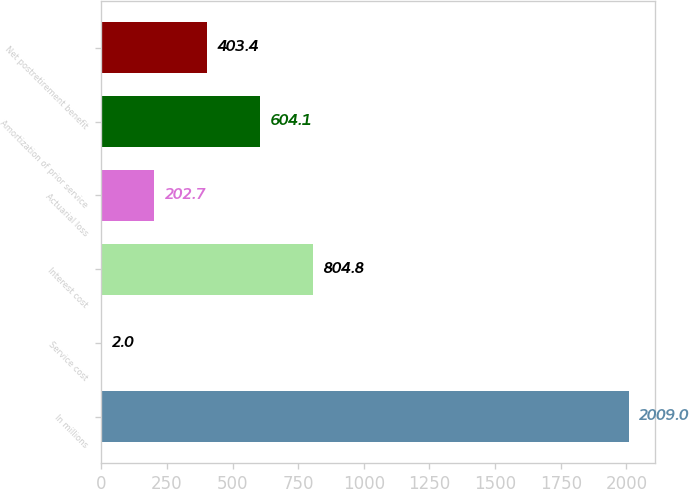Convert chart. <chart><loc_0><loc_0><loc_500><loc_500><bar_chart><fcel>In millions<fcel>Service cost<fcel>Interest cost<fcel>Actuarial loss<fcel>Amortization of prior service<fcel>Net postretirement benefit<nl><fcel>2009<fcel>2<fcel>804.8<fcel>202.7<fcel>604.1<fcel>403.4<nl></chart> 